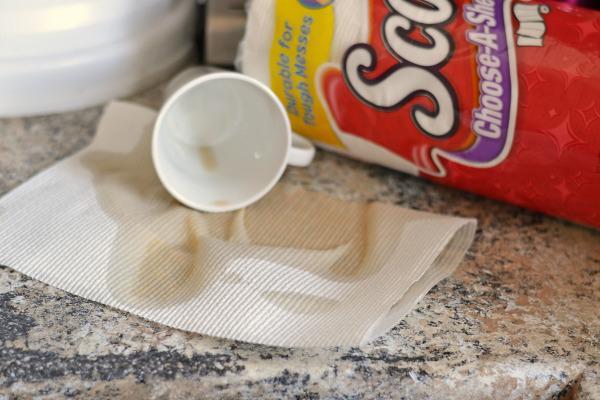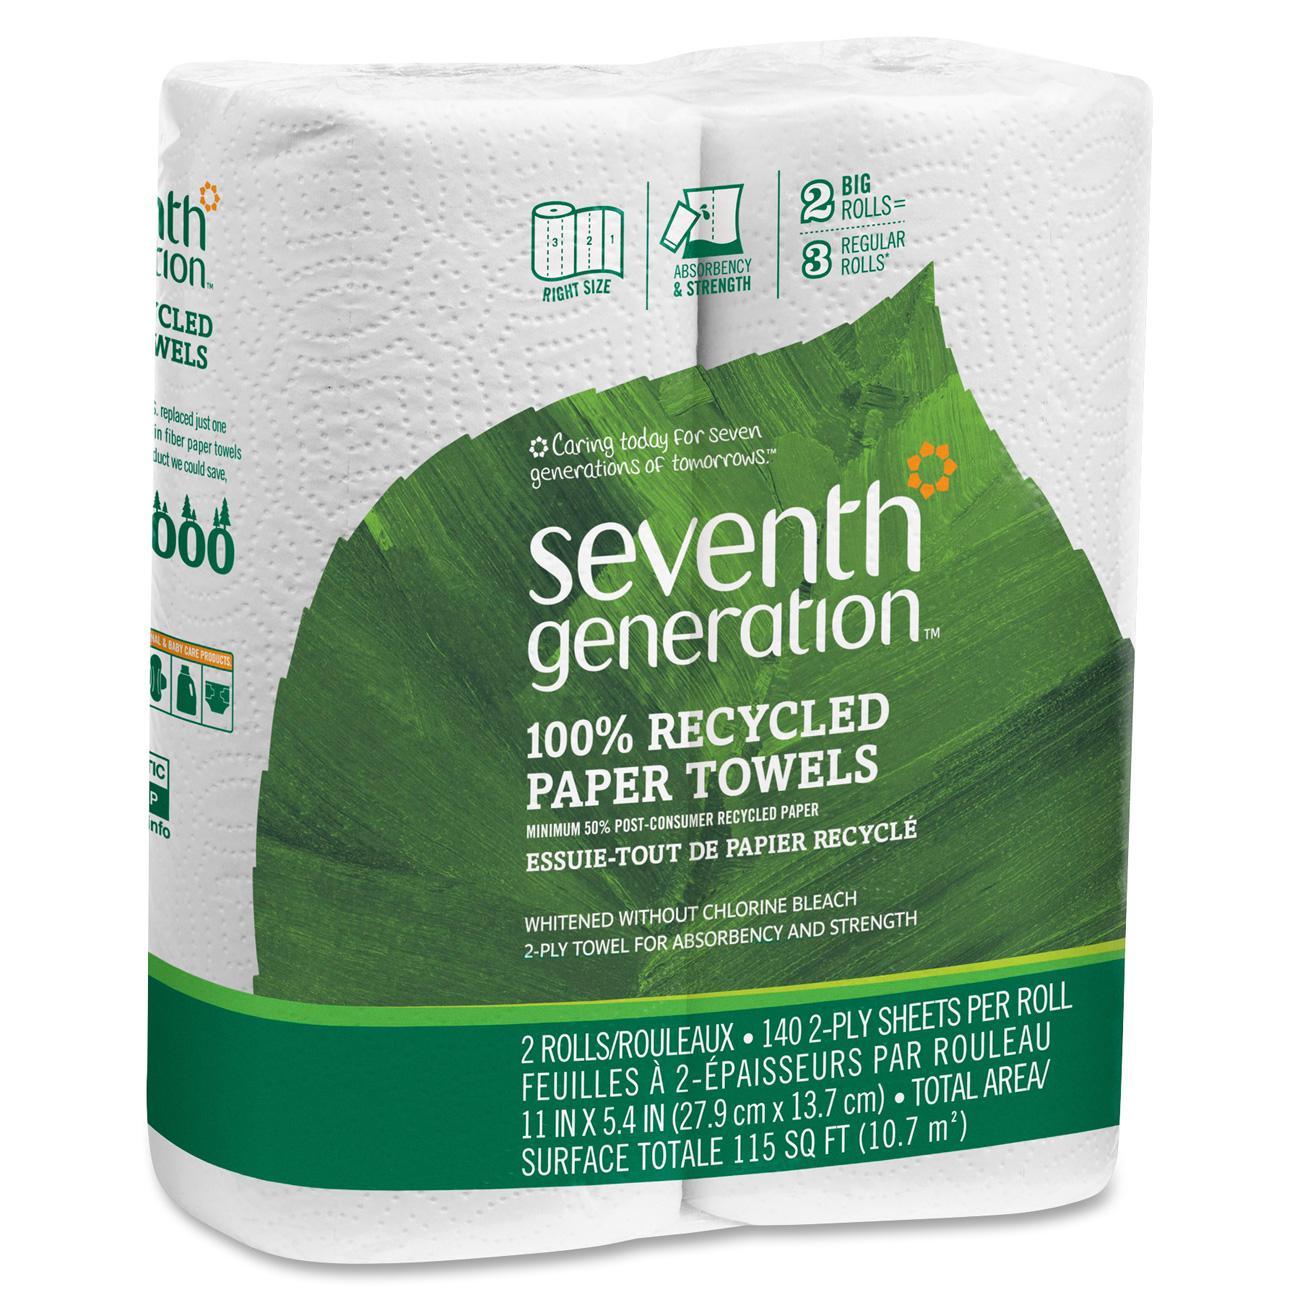The first image is the image on the left, the second image is the image on the right. Given the left and right images, does the statement "Each image shows only a sealed package of paper towels and no package contains more than three rolls." hold true? Answer yes or no. No. The first image is the image on the left, the second image is the image on the right. Examine the images to the left and right. Is the description "An image includes some amount of paper towel that is not in its wrapped package." accurate? Answer yes or no. Yes. 